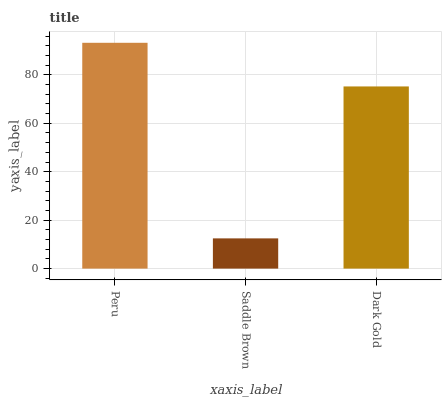Is Saddle Brown the minimum?
Answer yes or no. Yes. Is Peru the maximum?
Answer yes or no. Yes. Is Dark Gold the minimum?
Answer yes or no. No. Is Dark Gold the maximum?
Answer yes or no. No. Is Dark Gold greater than Saddle Brown?
Answer yes or no. Yes. Is Saddle Brown less than Dark Gold?
Answer yes or no. Yes. Is Saddle Brown greater than Dark Gold?
Answer yes or no. No. Is Dark Gold less than Saddle Brown?
Answer yes or no. No. Is Dark Gold the high median?
Answer yes or no. Yes. Is Dark Gold the low median?
Answer yes or no. Yes. Is Saddle Brown the high median?
Answer yes or no. No. Is Saddle Brown the low median?
Answer yes or no. No. 